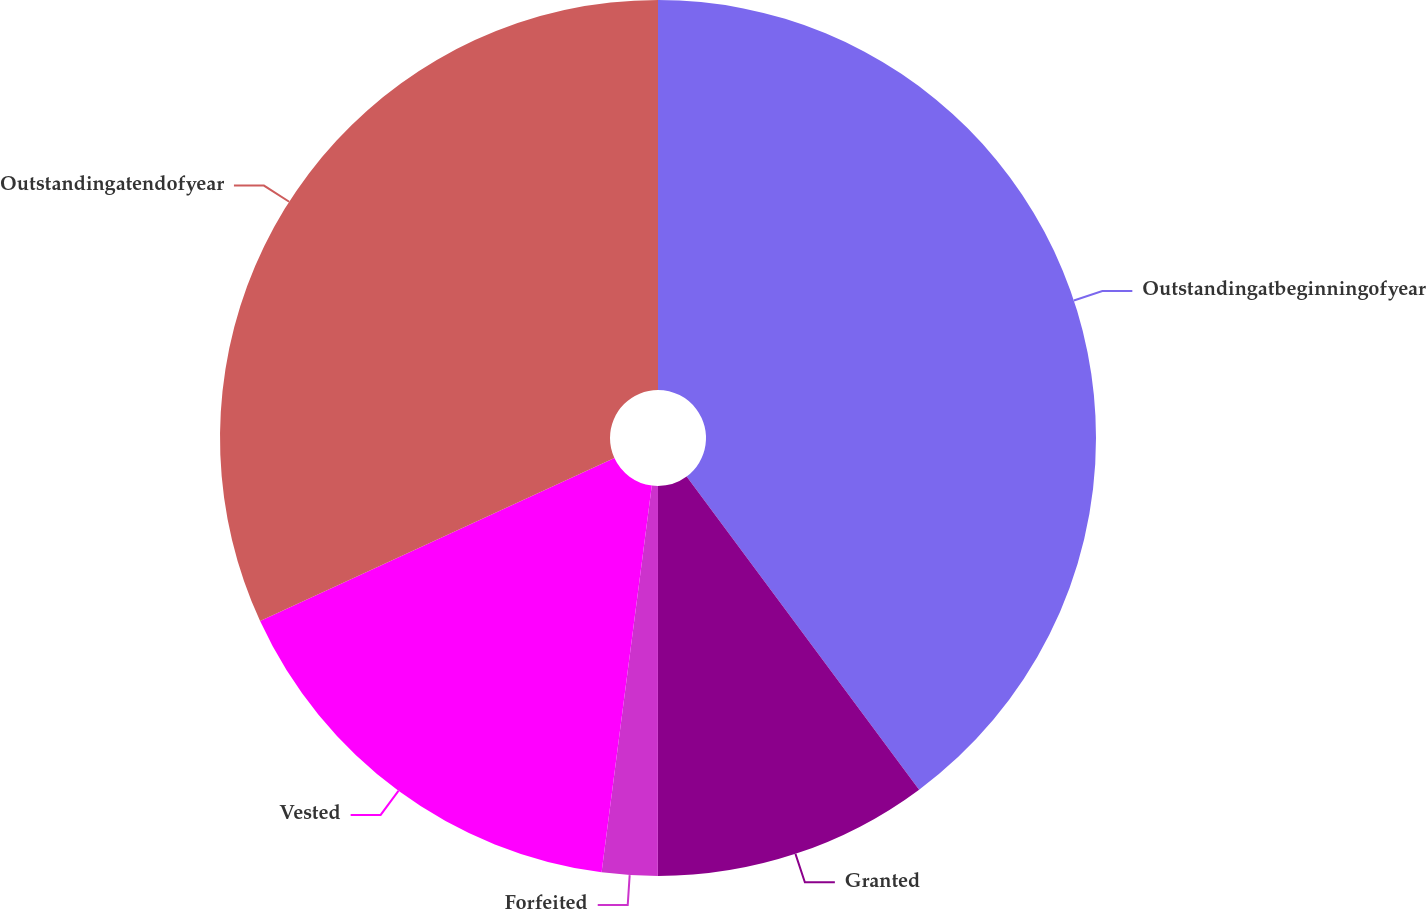<chart> <loc_0><loc_0><loc_500><loc_500><pie_chart><fcel>Outstandingatbeginningofyear<fcel>Granted<fcel>Forfeited<fcel>Vested<fcel>Outstandingatendofyear<nl><fcel>39.83%<fcel>10.17%<fcel>2.05%<fcel>16.08%<fcel>31.86%<nl></chart> 